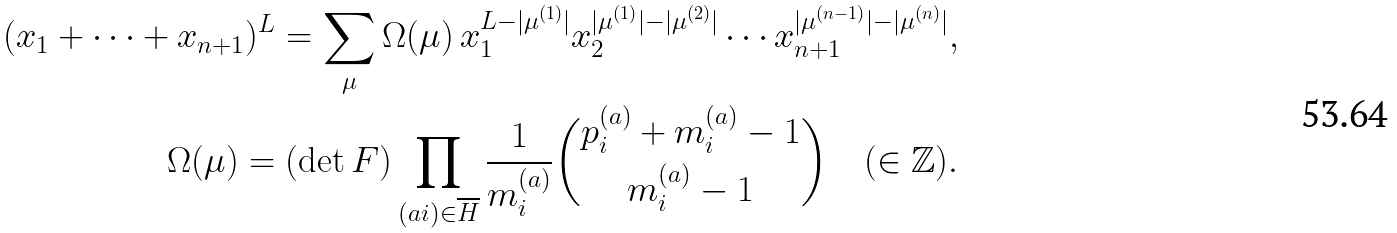Convert formula to latex. <formula><loc_0><loc_0><loc_500><loc_500>( x _ { 1 } + \cdots + x _ { n + 1 } ) ^ { L } = \sum _ { \mu } \Omega ( \mu ) \, x _ { 1 } ^ { L - | \mu ^ { ( 1 ) } | } x _ { 2 } ^ { | \mu ^ { ( 1 ) } | - | \mu ^ { ( 2 ) } | } \cdots x _ { n + 1 } ^ { | \mu ^ { ( n - 1 ) } | - | \mu ^ { ( n ) } | } , \\ \Omega ( \mu ) = ( \det F ) \prod _ { ( a i ) \in \overline { H } } \frac { 1 } { m _ { i } ^ { ( a ) } } \binom { p _ { i } ^ { ( a ) } + m _ { i } ^ { ( a ) } - 1 } { m _ { i } ^ { ( a ) } - 1 } \quad ( \in { \mathbb { Z } } ) .</formula> 